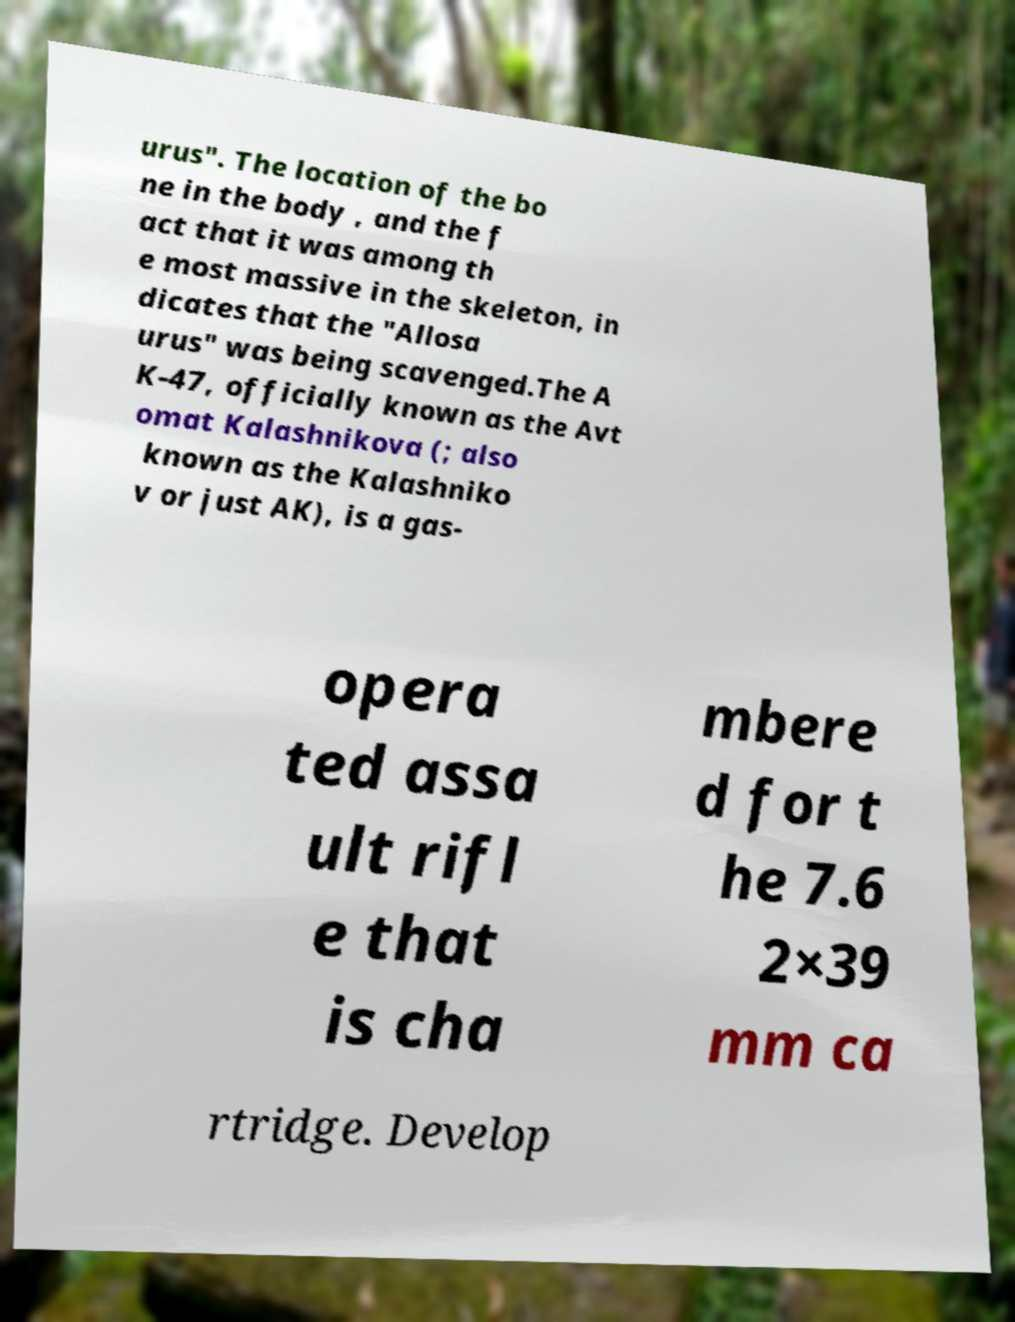Can you read and provide the text displayed in the image?This photo seems to have some interesting text. Can you extract and type it out for me? urus". The location of the bo ne in the body , and the f act that it was among th e most massive in the skeleton, in dicates that the "Allosa urus" was being scavenged.The A K-47, officially known as the Avt omat Kalashnikova (; also known as the Kalashniko v or just AK), is a gas- opera ted assa ult rifl e that is cha mbere d for t he 7.6 2×39 mm ca rtridge. Develop 